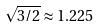Convert formula to latex. <formula><loc_0><loc_0><loc_500><loc_500>\sqrt { 3 / 2 } \approx 1 . 2 2 5</formula> 